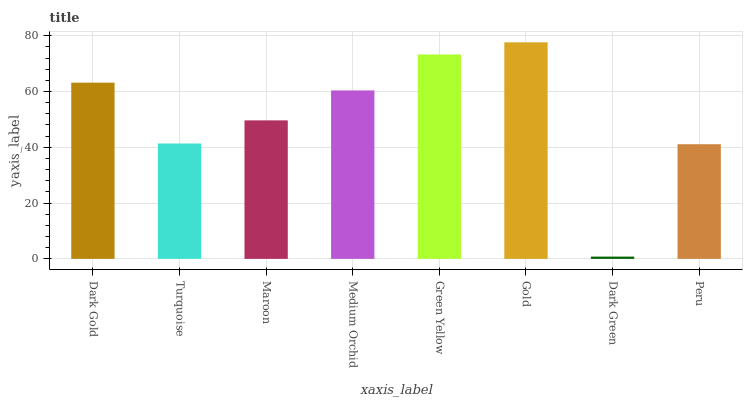Is Dark Green the minimum?
Answer yes or no. Yes. Is Gold the maximum?
Answer yes or no. Yes. Is Turquoise the minimum?
Answer yes or no. No. Is Turquoise the maximum?
Answer yes or no. No. Is Dark Gold greater than Turquoise?
Answer yes or no. Yes. Is Turquoise less than Dark Gold?
Answer yes or no. Yes. Is Turquoise greater than Dark Gold?
Answer yes or no. No. Is Dark Gold less than Turquoise?
Answer yes or no. No. Is Medium Orchid the high median?
Answer yes or no. Yes. Is Maroon the low median?
Answer yes or no. Yes. Is Dark Gold the high median?
Answer yes or no. No. Is Turquoise the low median?
Answer yes or no. No. 